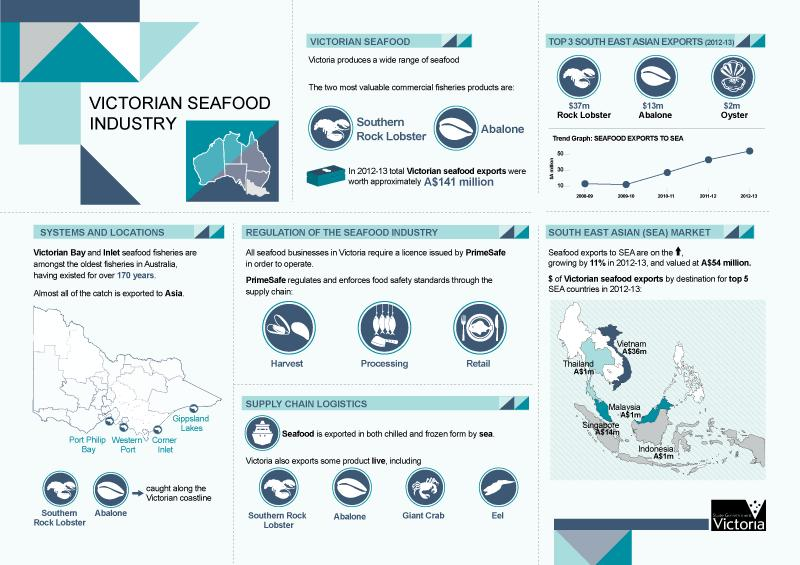Identify some key points in this picture. In 2012-13, Vietnam was the South East Asian country with the highest value of Victorian seafood exports. According to data from the year 2012-2013, the value of seafood exports from Malaysia during that time period was approximately A$1 million. In 2012-2013, Singapore was the South East Asian country with the second highest value of Victorian seafood exports. In the year 2012-13, the total worth of Victorian seafood exports was A$141 million. The rock lobster was the top product in southeast Asian exports in the year 2012-2013. 